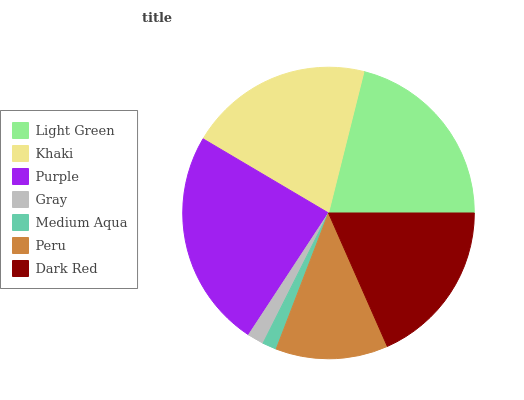Is Medium Aqua the minimum?
Answer yes or no. Yes. Is Purple the maximum?
Answer yes or no. Yes. Is Khaki the minimum?
Answer yes or no. No. Is Khaki the maximum?
Answer yes or no. No. Is Light Green greater than Khaki?
Answer yes or no. Yes. Is Khaki less than Light Green?
Answer yes or no. Yes. Is Khaki greater than Light Green?
Answer yes or no. No. Is Light Green less than Khaki?
Answer yes or no. No. Is Dark Red the high median?
Answer yes or no. Yes. Is Dark Red the low median?
Answer yes or no. Yes. Is Gray the high median?
Answer yes or no. No. Is Peru the low median?
Answer yes or no. No. 